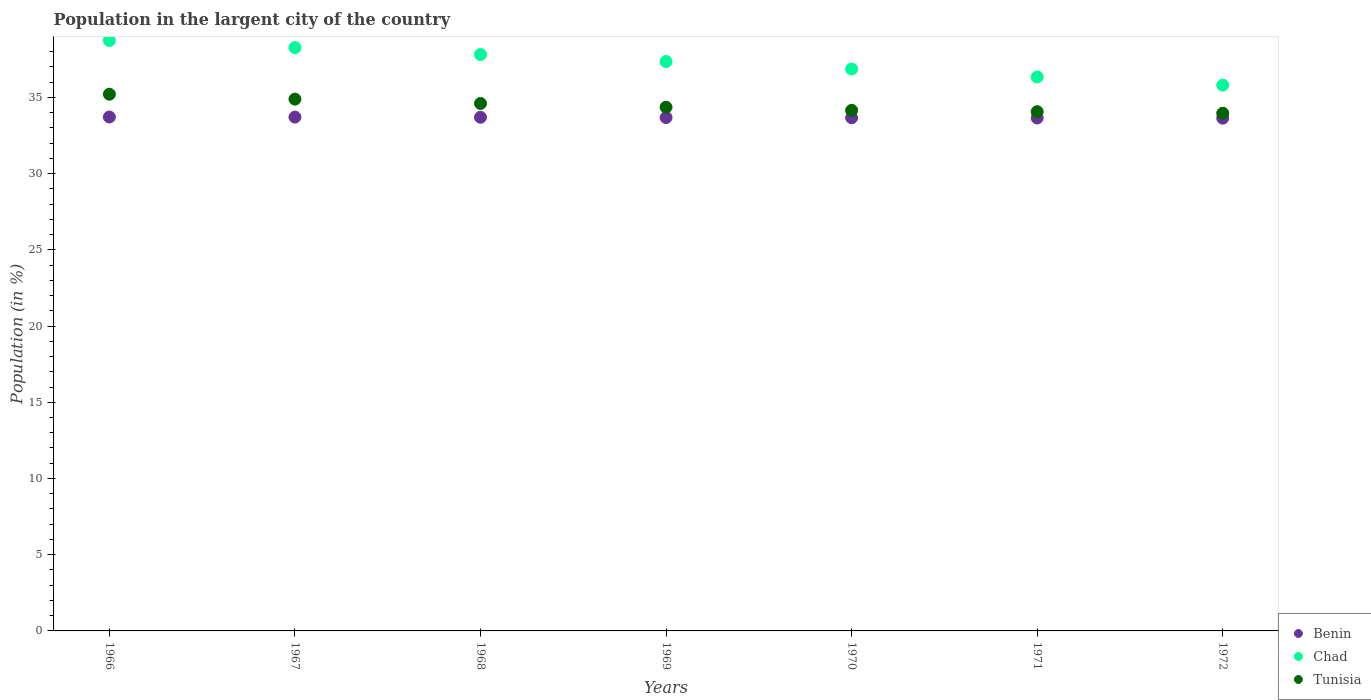Is the number of dotlines equal to the number of legend labels?
Give a very brief answer. Yes. What is the percentage of population in the largent city in Chad in 1966?
Your answer should be very brief. 38.73. Across all years, what is the maximum percentage of population in the largent city in Tunisia?
Offer a terse response. 35.21. Across all years, what is the minimum percentage of population in the largent city in Benin?
Provide a short and direct response. 33.64. In which year was the percentage of population in the largent city in Tunisia maximum?
Your response must be concise. 1966. What is the total percentage of population in the largent city in Benin in the graph?
Offer a terse response. 235.74. What is the difference between the percentage of population in the largent city in Benin in 1969 and that in 1970?
Offer a terse response. 0.02. What is the difference between the percentage of population in the largent city in Benin in 1966 and the percentage of population in the largent city in Chad in 1970?
Offer a terse response. -3.15. What is the average percentage of population in the largent city in Benin per year?
Provide a short and direct response. 33.68. In the year 1969, what is the difference between the percentage of population in the largent city in Benin and percentage of population in the largent city in Tunisia?
Your response must be concise. -0.68. In how many years, is the percentage of population in the largent city in Tunisia greater than 26 %?
Your answer should be compact. 7. What is the ratio of the percentage of population in the largent city in Benin in 1971 to that in 1972?
Your response must be concise. 1. Is the percentage of population in the largent city in Chad in 1968 less than that in 1970?
Offer a terse response. No. Is the difference between the percentage of population in the largent city in Benin in 1970 and 1971 greater than the difference between the percentage of population in the largent city in Tunisia in 1970 and 1971?
Give a very brief answer. No. What is the difference between the highest and the second highest percentage of population in the largent city in Tunisia?
Provide a short and direct response. 0.32. What is the difference between the highest and the lowest percentage of population in the largent city in Chad?
Give a very brief answer. 2.93. In how many years, is the percentage of population in the largent city in Chad greater than the average percentage of population in the largent city in Chad taken over all years?
Ensure brevity in your answer.  4. Is the sum of the percentage of population in the largent city in Chad in 1968 and 1969 greater than the maximum percentage of population in the largent city in Tunisia across all years?
Make the answer very short. Yes. Does the percentage of population in the largent city in Chad monotonically increase over the years?
Your answer should be very brief. No. Is the percentage of population in the largent city in Benin strictly less than the percentage of population in the largent city in Chad over the years?
Give a very brief answer. Yes. How many dotlines are there?
Provide a succinct answer. 3. How many years are there in the graph?
Keep it short and to the point. 7. Are the values on the major ticks of Y-axis written in scientific E-notation?
Ensure brevity in your answer.  No. Does the graph contain grids?
Offer a terse response. No. How many legend labels are there?
Offer a terse response. 3. What is the title of the graph?
Your response must be concise. Population in the largent city of the country. Does "Malaysia" appear as one of the legend labels in the graph?
Make the answer very short. No. What is the label or title of the Y-axis?
Provide a succinct answer. Population (in %). What is the Population (in %) in Benin in 1966?
Give a very brief answer. 33.71. What is the Population (in %) in Chad in 1966?
Your response must be concise. 38.73. What is the Population (in %) of Tunisia in 1966?
Your answer should be very brief. 35.21. What is the Population (in %) in Benin in 1967?
Keep it short and to the point. 33.71. What is the Population (in %) in Chad in 1967?
Your response must be concise. 38.27. What is the Population (in %) in Tunisia in 1967?
Provide a succinct answer. 34.89. What is the Population (in %) in Benin in 1968?
Ensure brevity in your answer.  33.7. What is the Population (in %) in Chad in 1968?
Keep it short and to the point. 37.81. What is the Population (in %) in Tunisia in 1968?
Provide a succinct answer. 34.6. What is the Population (in %) of Benin in 1969?
Keep it short and to the point. 33.68. What is the Population (in %) in Chad in 1969?
Your response must be concise. 37.35. What is the Population (in %) in Tunisia in 1969?
Provide a short and direct response. 34.36. What is the Population (in %) of Benin in 1970?
Offer a terse response. 33.66. What is the Population (in %) of Chad in 1970?
Your answer should be compact. 36.86. What is the Population (in %) in Tunisia in 1970?
Offer a very short reply. 34.15. What is the Population (in %) of Benin in 1971?
Offer a very short reply. 33.65. What is the Population (in %) of Chad in 1971?
Offer a terse response. 36.34. What is the Population (in %) of Tunisia in 1971?
Provide a succinct answer. 34.06. What is the Population (in %) in Benin in 1972?
Make the answer very short. 33.64. What is the Population (in %) in Chad in 1972?
Ensure brevity in your answer.  35.8. What is the Population (in %) of Tunisia in 1972?
Keep it short and to the point. 33.96. Across all years, what is the maximum Population (in %) of Benin?
Ensure brevity in your answer.  33.71. Across all years, what is the maximum Population (in %) of Chad?
Make the answer very short. 38.73. Across all years, what is the maximum Population (in %) of Tunisia?
Make the answer very short. 35.21. Across all years, what is the minimum Population (in %) of Benin?
Offer a terse response. 33.64. Across all years, what is the minimum Population (in %) in Chad?
Your response must be concise. 35.8. Across all years, what is the minimum Population (in %) in Tunisia?
Your response must be concise. 33.96. What is the total Population (in %) in Benin in the graph?
Ensure brevity in your answer.  235.74. What is the total Population (in %) of Chad in the graph?
Your answer should be compact. 261.17. What is the total Population (in %) of Tunisia in the graph?
Keep it short and to the point. 241.23. What is the difference between the Population (in %) in Benin in 1966 and that in 1967?
Offer a very short reply. 0.01. What is the difference between the Population (in %) in Chad in 1966 and that in 1967?
Offer a terse response. 0.47. What is the difference between the Population (in %) of Tunisia in 1966 and that in 1967?
Ensure brevity in your answer.  0.32. What is the difference between the Population (in %) of Benin in 1966 and that in 1968?
Offer a very short reply. 0.02. What is the difference between the Population (in %) of Chad in 1966 and that in 1968?
Ensure brevity in your answer.  0.92. What is the difference between the Population (in %) of Tunisia in 1966 and that in 1968?
Your answer should be compact. 0.61. What is the difference between the Population (in %) of Benin in 1966 and that in 1969?
Keep it short and to the point. 0.04. What is the difference between the Population (in %) of Chad in 1966 and that in 1969?
Your response must be concise. 1.38. What is the difference between the Population (in %) in Tunisia in 1966 and that in 1969?
Offer a very short reply. 0.85. What is the difference between the Population (in %) in Benin in 1966 and that in 1970?
Ensure brevity in your answer.  0.05. What is the difference between the Population (in %) in Chad in 1966 and that in 1970?
Your answer should be very brief. 1.87. What is the difference between the Population (in %) of Tunisia in 1966 and that in 1970?
Provide a short and direct response. 1.06. What is the difference between the Population (in %) of Benin in 1966 and that in 1971?
Keep it short and to the point. 0.07. What is the difference between the Population (in %) of Chad in 1966 and that in 1971?
Offer a very short reply. 2.39. What is the difference between the Population (in %) of Tunisia in 1966 and that in 1971?
Give a very brief answer. 1.15. What is the difference between the Population (in %) in Benin in 1966 and that in 1972?
Your response must be concise. 0.08. What is the difference between the Population (in %) in Chad in 1966 and that in 1972?
Give a very brief answer. 2.93. What is the difference between the Population (in %) of Tunisia in 1966 and that in 1972?
Provide a short and direct response. 1.25. What is the difference between the Population (in %) in Benin in 1967 and that in 1968?
Offer a very short reply. 0.01. What is the difference between the Population (in %) in Chad in 1967 and that in 1968?
Provide a succinct answer. 0.45. What is the difference between the Population (in %) in Tunisia in 1967 and that in 1968?
Provide a succinct answer. 0.28. What is the difference between the Population (in %) in Benin in 1967 and that in 1969?
Your response must be concise. 0.03. What is the difference between the Population (in %) in Chad in 1967 and that in 1969?
Your answer should be very brief. 0.92. What is the difference between the Population (in %) of Tunisia in 1967 and that in 1969?
Give a very brief answer. 0.53. What is the difference between the Population (in %) of Benin in 1967 and that in 1970?
Ensure brevity in your answer.  0.05. What is the difference between the Population (in %) of Chad in 1967 and that in 1970?
Give a very brief answer. 1.41. What is the difference between the Population (in %) in Tunisia in 1967 and that in 1970?
Provide a succinct answer. 0.74. What is the difference between the Population (in %) in Benin in 1967 and that in 1971?
Offer a very short reply. 0.06. What is the difference between the Population (in %) in Chad in 1967 and that in 1971?
Your answer should be very brief. 1.93. What is the difference between the Population (in %) in Tunisia in 1967 and that in 1971?
Your answer should be very brief. 0.82. What is the difference between the Population (in %) in Benin in 1967 and that in 1972?
Your response must be concise. 0.07. What is the difference between the Population (in %) of Chad in 1967 and that in 1972?
Keep it short and to the point. 2.46. What is the difference between the Population (in %) of Tunisia in 1967 and that in 1972?
Ensure brevity in your answer.  0.92. What is the difference between the Population (in %) in Benin in 1968 and that in 1969?
Ensure brevity in your answer.  0.02. What is the difference between the Population (in %) in Chad in 1968 and that in 1969?
Make the answer very short. 0.46. What is the difference between the Population (in %) of Tunisia in 1968 and that in 1969?
Your answer should be compact. 0.25. What is the difference between the Population (in %) in Benin in 1968 and that in 1970?
Your answer should be very brief. 0.04. What is the difference between the Population (in %) of Chad in 1968 and that in 1970?
Offer a very short reply. 0.95. What is the difference between the Population (in %) of Tunisia in 1968 and that in 1970?
Keep it short and to the point. 0.45. What is the difference between the Population (in %) of Benin in 1968 and that in 1971?
Ensure brevity in your answer.  0.05. What is the difference between the Population (in %) of Chad in 1968 and that in 1971?
Your response must be concise. 1.47. What is the difference between the Population (in %) of Tunisia in 1968 and that in 1971?
Your answer should be very brief. 0.54. What is the difference between the Population (in %) in Benin in 1968 and that in 1972?
Ensure brevity in your answer.  0.06. What is the difference between the Population (in %) of Chad in 1968 and that in 1972?
Give a very brief answer. 2.01. What is the difference between the Population (in %) in Tunisia in 1968 and that in 1972?
Keep it short and to the point. 0.64. What is the difference between the Population (in %) in Benin in 1969 and that in 1970?
Provide a short and direct response. 0.02. What is the difference between the Population (in %) of Chad in 1969 and that in 1970?
Make the answer very short. 0.49. What is the difference between the Population (in %) of Tunisia in 1969 and that in 1970?
Offer a terse response. 0.21. What is the difference between the Population (in %) in Benin in 1969 and that in 1971?
Your answer should be very brief. 0.03. What is the difference between the Population (in %) in Chad in 1969 and that in 1971?
Offer a terse response. 1.01. What is the difference between the Population (in %) in Tunisia in 1969 and that in 1971?
Keep it short and to the point. 0.29. What is the difference between the Population (in %) in Benin in 1969 and that in 1972?
Your answer should be very brief. 0.04. What is the difference between the Population (in %) in Chad in 1969 and that in 1972?
Provide a short and direct response. 1.55. What is the difference between the Population (in %) in Tunisia in 1969 and that in 1972?
Offer a very short reply. 0.4. What is the difference between the Population (in %) in Benin in 1970 and that in 1971?
Your answer should be compact. 0.01. What is the difference between the Population (in %) in Chad in 1970 and that in 1971?
Provide a succinct answer. 0.52. What is the difference between the Population (in %) of Tunisia in 1970 and that in 1971?
Your response must be concise. 0.09. What is the difference between the Population (in %) in Benin in 1970 and that in 1972?
Ensure brevity in your answer.  0.03. What is the difference between the Population (in %) in Chad in 1970 and that in 1972?
Give a very brief answer. 1.06. What is the difference between the Population (in %) of Tunisia in 1970 and that in 1972?
Keep it short and to the point. 0.19. What is the difference between the Population (in %) in Benin in 1971 and that in 1972?
Your answer should be compact. 0.01. What is the difference between the Population (in %) of Chad in 1971 and that in 1972?
Your answer should be very brief. 0.54. What is the difference between the Population (in %) in Tunisia in 1971 and that in 1972?
Give a very brief answer. 0.1. What is the difference between the Population (in %) of Benin in 1966 and the Population (in %) of Chad in 1967?
Make the answer very short. -4.55. What is the difference between the Population (in %) of Benin in 1966 and the Population (in %) of Tunisia in 1967?
Give a very brief answer. -1.17. What is the difference between the Population (in %) of Chad in 1966 and the Population (in %) of Tunisia in 1967?
Offer a terse response. 3.85. What is the difference between the Population (in %) in Benin in 1966 and the Population (in %) in Chad in 1968?
Your answer should be compact. -4.1. What is the difference between the Population (in %) of Benin in 1966 and the Population (in %) of Tunisia in 1968?
Offer a terse response. -0.89. What is the difference between the Population (in %) in Chad in 1966 and the Population (in %) in Tunisia in 1968?
Your response must be concise. 4.13. What is the difference between the Population (in %) in Benin in 1966 and the Population (in %) in Chad in 1969?
Give a very brief answer. -3.64. What is the difference between the Population (in %) in Benin in 1966 and the Population (in %) in Tunisia in 1969?
Offer a terse response. -0.64. What is the difference between the Population (in %) of Chad in 1966 and the Population (in %) of Tunisia in 1969?
Offer a very short reply. 4.38. What is the difference between the Population (in %) of Benin in 1966 and the Population (in %) of Chad in 1970?
Provide a succinct answer. -3.15. What is the difference between the Population (in %) of Benin in 1966 and the Population (in %) of Tunisia in 1970?
Ensure brevity in your answer.  -0.44. What is the difference between the Population (in %) of Chad in 1966 and the Population (in %) of Tunisia in 1970?
Make the answer very short. 4.58. What is the difference between the Population (in %) of Benin in 1966 and the Population (in %) of Chad in 1971?
Provide a succinct answer. -2.63. What is the difference between the Population (in %) of Benin in 1966 and the Population (in %) of Tunisia in 1971?
Provide a short and direct response. -0.35. What is the difference between the Population (in %) in Chad in 1966 and the Population (in %) in Tunisia in 1971?
Provide a short and direct response. 4.67. What is the difference between the Population (in %) of Benin in 1966 and the Population (in %) of Chad in 1972?
Make the answer very short. -2.09. What is the difference between the Population (in %) of Benin in 1966 and the Population (in %) of Tunisia in 1972?
Provide a succinct answer. -0.25. What is the difference between the Population (in %) in Chad in 1966 and the Population (in %) in Tunisia in 1972?
Your answer should be very brief. 4.77. What is the difference between the Population (in %) of Benin in 1967 and the Population (in %) of Chad in 1968?
Offer a terse response. -4.11. What is the difference between the Population (in %) of Benin in 1967 and the Population (in %) of Tunisia in 1968?
Keep it short and to the point. -0.89. What is the difference between the Population (in %) in Chad in 1967 and the Population (in %) in Tunisia in 1968?
Your answer should be compact. 3.66. What is the difference between the Population (in %) of Benin in 1967 and the Population (in %) of Chad in 1969?
Give a very brief answer. -3.64. What is the difference between the Population (in %) in Benin in 1967 and the Population (in %) in Tunisia in 1969?
Keep it short and to the point. -0.65. What is the difference between the Population (in %) in Chad in 1967 and the Population (in %) in Tunisia in 1969?
Keep it short and to the point. 3.91. What is the difference between the Population (in %) of Benin in 1967 and the Population (in %) of Chad in 1970?
Keep it short and to the point. -3.15. What is the difference between the Population (in %) in Benin in 1967 and the Population (in %) in Tunisia in 1970?
Offer a very short reply. -0.44. What is the difference between the Population (in %) of Chad in 1967 and the Population (in %) of Tunisia in 1970?
Offer a very short reply. 4.12. What is the difference between the Population (in %) in Benin in 1967 and the Population (in %) in Chad in 1971?
Your answer should be compact. -2.63. What is the difference between the Population (in %) of Benin in 1967 and the Population (in %) of Tunisia in 1971?
Make the answer very short. -0.36. What is the difference between the Population (in %) in Chad in 1967 and the Population (in %) in Tunisia in 1971?
Your response must be concise. 4.2. What is the difference between the Population (in %) of Benin in 1967 and the Population (in %) of Chad in 1972?
Provide a short and direct response. -2.1. What is the difference between the Population (in %) of Benin in 1967 and the Population (in %) of Tunisia in 1972?
Offer a terse response. -0.25. What is the difference between the Population (in %) of Chad in 1967 and the Population (in %) of Tunisia in 1972?
Ensure brevity in your answer.  4.31. What is the difference between the Population (in %) of Benin in 1968 and the Population (in %) of Chad in 1969?
Offer a terse response. -3.65. What is the difference between the Population (in %) in Benin in 1968 and the Population (in %) in Tunisia in 1969?
Make the answer very short. -0.66. What is the difference between the Population (in %) of Chad in 1968 and the Population (in %) of Tunisia in 1969?
Provide a succinct answer. 3.46. What is the difference between the Population (in %) of Benin in 1968 and the Population (in %) of Chad in 1970?
Ensure brevity in your answer.  -3.16. What is the difference between the Population (in %) in Benin in 1968 and the Population (in %) in Tunisia in 1970?
Provide a short and direct response. -0.45. What is the difference between the Population (in %) of Chad in 1968 and the Population (in %) of Tunisia in 1970?
Make the answer very short. 3.66. What is the difference between the Population (in %) in Benin in 1968 and the Population (in %) in Chad in 1971?
Give a very brief answer. -2.64. What is the difference between the Population (in %) in Benin in 1968 and the Population (in %) in Tunisia in 1971?
Offer a terse response. -0.37. What is the difference between the Population (in %) in Chad in 1968 and the Population (in %) in Tunisia in 1971?
Your answer should be very brief. 3.75. What is the difference between the Population (in %) in Benin in 1968 and the Population (in %) in Chad in 1972?
Provide a short and direct response. -2.11. What is the difference between the Population (in %) of Benin in 1968 and the Population (in %) of Tunisia in 1972?
Provide a short and direct response. -0.26. What is the difference between the Population (in %) in Chad in 1968 and the Population (in %) in Tunisia in 1972?
Your answer should be compact. 3.85. What is the difference between the Population (in %) in Benin in 1969 and the Population (in %) in Chad in 1970?
Your answer should be very brief. -3.18. What is the difference between the Population (in %) of Benin in 1969 and the Population (in %) of Tunisia in 1970?
Your answer should be compact. -0.47. What is the difference between the Population (in %) of Chad in 1969 and the Population (in %) of Tunisia in 1970?
Your response must be concise. 3.2. What is the difference between the Population (in %) of Benin in 1969 and the Population (in %) of Chad in 1971?
Your response must be concise. -2.66. What is the difference between the Population (in %) of Benin in 1969 and the Population (in %) of Tunisia in 1971?
Make the answer very short. -0.38. What is the difference between the Population (in %) of Chad in 1969 and the Population (in %) of Tunisia in 1971?
Your answer should be compact. 3.29. What is the difference between the Population (in %) in Benin in 1969 and the Population (in %) in Chad in 1972?
Keep it short and to the point. -2.13. What is the difference between the Population (in %) of Benin in 1969 and the Population (in %) of Tunisia in 1972?
Your answer should be compact. -0.28. What is the difference between the Population (in %) of Chad in 1969 and the Population (in %) of Tunisia in 1972?
Your response must be concise. 3.39. What is the difference between the Population (in %) of Benin in 1970 and the Population (in %) of Chad in 1971?
Keep it short and to the point. -2.68. What is the difference between the Population (in %) in Benin in 1970 and the Population (in %) in Tunisia in 1971?
Make the answer very short. -0.4. What is the difference between the Population (in %) of Chad in 1970 and the Population (in %) of Tunisia in 1971?
Offer a very short reply. 2.8. What is the difference between the Population (in %) in Benin in 1970 and the Population (in %) in Chad in 1972?
Give a very brief answer. -2.14. What is the difference between the Population (in %) in Benin in 1970 and the Population (in %) in Tunisia in 1972?
Give a very brief answer. -0.3. What is the difference between the Population (in %) in Chad in 1970 and the Population (in %) in Tunisia in 1972?
Ensure brevity in your answer.  2.9. What is the difference between the Population (in %) of Benin in 1971 and the Population (in %) of Chad in 1972?
Your response must be concise. -2.16. What is the difference between the Population (in %) in Benin in 1971 and the Population (in %) in Tunisia in 1972?
Ensure brevity in your answer.  -0.31. What is the difference between the Population (in %) of Chad in 1971 and the Population (in %) of Tunisia in 1972?
Your answer should be compact. 2.38. What is the average Population (in %) in Benin per year?
Offer a very short reply. 33.68. What is the average Population (in %) in Chad per year?
Offer a very short reply. 37.31. What is the average Population (in %) of Tunisia per year?
Keep it short and to the point. 34.46. In the year 1966, what is the difference between the Population (in %) of Benin and Population (in %) of Chad?
Your answer should be compact. -5.02. In the year 1966, what is the difference between the Population (in %) of Benin and Population (in %) of Tunisia?
Provide a succinct answer. -1.49. In the year 1966, what is the difference between the Population (in %) in Chad and Population (in %) in Tunisia?
Make the answer very short. 3.53. In the year 1967, what is the difference between the Population (in %) of Benin and Population (in %) of Chad?
Ensure brevity in your answer.  -4.56. In the year 1967, what is the difference between the Population (in %) of Benin and Population (in %) of Tunisia?
Keep it short and to the point. -1.18. In the year 1967, what is the difference between the Population (in %) in Chad and Population (in %) in Tunisia?
Your response must be concise. 3.38. In the year 1968, what is the difference between the Population (in %) in Benin and Population (in %) in Chad?
Ensure brevity in your answer.  -4.12. In the year 1968, what is the difference between the Population (in %) in Benin and Population (in %) in Tunisia?
Your answer should be compact. -0.91. In the year 1968, what is the difference between the Population (in %) of Chad and Population (in %) of Tunisia?
Make the answer very short. 3.21. In the year 1969, what is the difference between the Population (in %) in Benin and Population (in %) in Chad?
Make the answer very short. -3.67. In the year 1969, what is the difference between the Population (in %) of Benin and Population (in %) of Tunisia?
Your answer should be very brief. -0.68. In the year 1969, what is the difference between the Population (in %) of Chad and Population (in %) of Tunisia?
Provide a succinct answer. 2.99. In the year 1970, what is the difference between the Population (in %) in Benin and Population (in %) in Chad?
Offer a very short reply. -3.2. In the year 1970, what is the difference between the Population (in %) in Benin and Population (in %) in Tunisia?
Provide a succinct answer. -0.49. In the year 1970, what is the difference between the Population (in %) of Chad and Population (in %) of Tunisia?
Provide a succinct answer. 2.71. In the year 1971, what is the difference between the Population (in %) of Benin and Population (in %) of Chad?
Make the answer very short. -2.69. In the year 1971, what is the difference between the Population (in %) in Benin and Population (in %) in Tunisia?
Your answer should be compact. -0.41. In the year 1971, what is the difference between the Population (in %) of Chad and Population (in %) of Tunisia?
Make the answer very short. 2.28. In the year 1972, what is the difference between the Population (in %) of Benin and Population (in %) of Chad?
Offer a terse response. -2.17. In the year 1972, what is the difference between the Population (in %) of Benin and Population (in %) of Tunisia?
Provide a succinct answer. -0.33. In the year 1972, what is the difference between the Population (in %) of Chad and Population (in %) of Tunisia?
Your answer should be very brief. 1.84. What is the ratio of the Population (in %) in Chad in 1966 to that in 1967?
Your response must be concise. 1.01. What is the ratio of the Population (in %) of Tunisia in 1966 to that in 1967?
Make the answer very short. 1.01. What is the ratio of the Population (in %) in Chad in 1966 to that in 1968?
Your response must be concise. 1.02. What is the ratio of the Population (in %) in Tunisia in 1966 to that in 1968?
Offer a very short reply. 1.02. What is the ratio of the Population (in %) of Benin in 1966 to that in 1969?
Offer a terse response. 1. What is the ratio of the Population (in %) of Chad in 1966 to that in 1969?
Ensure brevity in your answer.  1.04. What is the ratio of the Population (in %) of Tunisia in 1966 to that in 1969?
Offer a very short reply. 1.02. What is the ratio of the Population (in %) of Benin in 1966 to that in 1970?
Offer a very short reply. 1. What is the ratio of the Population (in %) of Chad in 1966 to that in 1970?
Your answer should be compact. 1.05. What is the ratio of the Population (in %) in Tunisia in 1966 to that in 1970?
Your response must be concise. 1.03. What is the ratio of the Population (in %) in Benin in 1966 to that in 1971?
Offer a very short reply. 1. What is the ratio of the Population (in %) in Chad in 1966 to that in 1971?
Offer a terse response. 1.07. What is the ratio of the Population (in %) in Tunisia in 1966 to that in 1971?
Your response must be concise. 1.03. What is the ratio of the Population (in %) of Chad in 1966 to that in 1972?
Your response must be concise. 1.08. What is the ratio of the Population (in %) in Tunisia in 1966 to that in 1972?
Ensure brevity in your answer.  1.04. What is the ratio of the Population (in %) in Benin in 1967 to that in 1968?
Offer a terse response. 1. What is the ratio of the Population (in %) in Chad in 1967 to that in 1968?
Your response must be concise. 1.01. What is the ratio of the Population (in %) in Tunisia in 1967 to that in 1968?
Give a very brief answer. 1.01. What is the ratio of the Population (in %) in Benin in 1967 to that in 1969?
Provide a short and direct response. 1. What is the ratio of the Population (in %) in Chad in 1967 to that in 1969?
Your answer should be compact. 1.02. What is the ratio of the Population (in %) of Tunisia in 1967 to that in 1969?
Provide a succinct answer. 1.02. What is the ratio of the Population (in %) in Chad in 1967 to that in 1970?
Keep it short and to the point. 1.04. What is the ratio of the Population (in %) in Tunisia in 1967 to that in 1970?
Keep it short and to the point. 1.02. What is the ratio of the Population (in %) in Benin in 1967 to that in 1971?
Provide a short and direct response. 1. What is the ratio of the Population (in %) in Chad in 1967 to that in 1971?
Your answer should be compact. 1.05. What is the ratio of the Population (in %) in Tunisia in 1967 to that in 1971?
Your answer should be compact. 1.02. What is the ratio of the Population (in %) of Benin in 1967 to that in 1972?
Give a very brief answer. 1. What is the ratio of the Population (in %) of Chad in 1967 to that in 1972?
Your answer should be compact. 1.07. What is the ratio of the Population (in %) in Tunisia in 1967 to that in 1972?
Provide a succinct answer. 1.03. What is the ratio of the Population (in %) of Chad in 1968 to that in 1969?
Offer a very short reply. 1.01. What is the ratio of the Population (in %) of Tunisia in 1968 to that in 1969?
Give a very brief answer. 1.01. What is the ratio of the Population (in %) in Chad in 1968 to that in 1970?
Provide a succinct answer. 1.03. What is the ratio of the Population (in %) in Tunisia in 1968 to that in 1970?
Keep it short and to the point. 1.01. What is the ratio of the Population (in %) in Benin in 1968 to that in 1971?
Your answer should be very brief. 1. What is the ratio of the Population (in %) in Chad in 1968 to that in 1971?
Give a very brief answer. 1.04. What is the ratio of the Population (in %) in Tunisia in 1968 to that in 1971?
Make the answer very short. 1.02. What is the ratio of the Population (in %) of Benin in 1968 to that in 1972?
Your answer should be very brief. 1. What is the ratio of the Population (in %) in Chad in 1968 to that in 1972?
Your response must be concise. 1.06. What is the ratio of the Population (in %) of Tunisia in 1968 to that in 1972?
Your response must be concise. 1.02. What is the ratio of the Population (in %) of Chad in 1969 to that in 1970?
Ensure brevity in your answer.  1.01. What is the ratio of the Population (in %) of Tunisia in 1969 to that in 1970?
Offer a terse response. 1.01. What is the ratio of the Population (in %) of Benin in 1969 to that in 1971?
Your answer should be very brief. 1. What is the ratio of the Population (in %) in Chad in 1969 to that in 1971?
Offer a terse response. 1.03. What is the ratio of the Population (in %) of Tunisia in 1969 to that in 1971?
Provide a succinct answer. 1.01. What is the ratio of the Population (in %) in Chad in 1969 to that in 1972?
Offer a terse response. 1.04. What is the ratio of the Population (in %) in Tunisia in 1969 to that in 1972?
Your answer should be very brief. 1.01. What is the ratio of the Population (in %) in Chad in 1970 to that in 1971?
Make the answer very short. 1.01. What is the ratio of the Population (in %) in Tunisia in 1970 to that in 1971?
Provide a short and direct response. 1. What is the ratio of the Population (in %) of Benin in 1970 to that in 1972?
Offer a terse response. 1. What is the ratio of the Population (in %) of Chad in 1970 to that in 1972?
Give a very brief answer. 1.03. What is the ratio of the Population (in %) in Tunisia in 1970 to that in 1972?
Give a very brief answer. 1.01. What is the ratio of the Population (in %) in Benin in 1971 to that in 1972?
Your answer should be very brief. 1. What is the difference between the highest and the second highest Population (in %) of Benin?
Your answer should be very brief. 0.01. What is the difference between the highest and the second highest Population (in %) in Chad?
Ensure brevity in your answer.  0.47. What is the difference between the highest and the second highest Population (in %) of Tunisia?
Give a very brief answer. 0.32. What is the difference between the highest and the lowest Population (in %) of Benin?
Provide a short and direct response. 0.08. What is the difference between the highest and the lowest Population (in %) of Chad?
Your answer should be very brief. 2.93. What is the difference between the highest and the lowest Population (in %) of Tunisia?
Your answer should be compact. 1.25. 